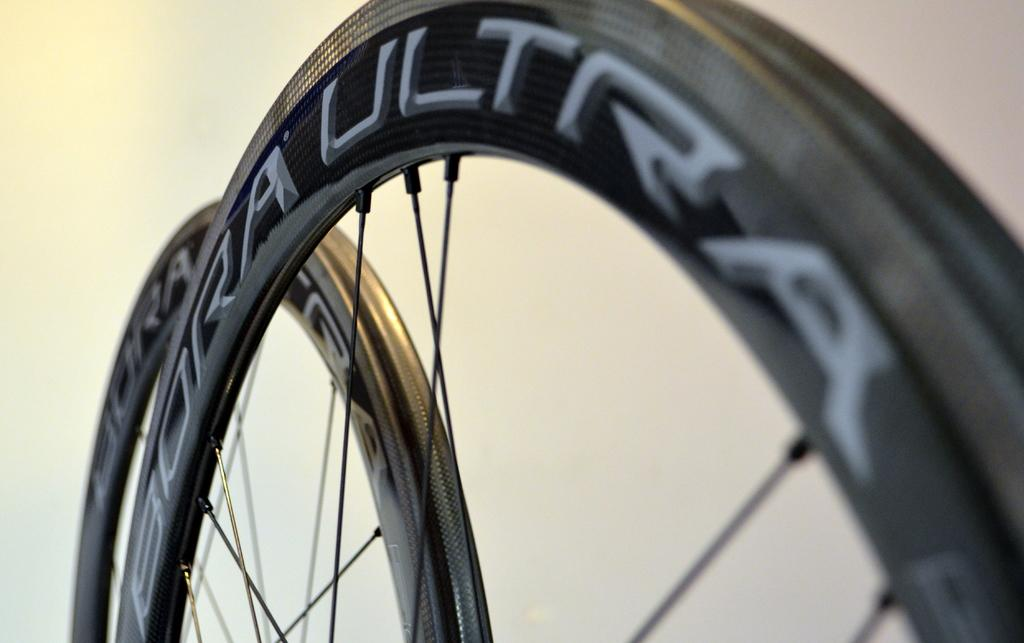What objects in the image have wheels? There are two wheels in the image. What is written or depicted on the wheels? There is text on the wheels. What can be seen in the background of the image? There is a wall in the background of the image. What color is the background of the image? The background of the image is white in color. How many actors are performing on the wheels in the image? There are no actors present in the image, and the wheels are not a stage for any performance. 